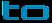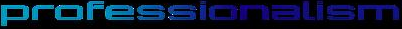What text appears in these images from left to right, separated by a semicolon? to; professionalism 